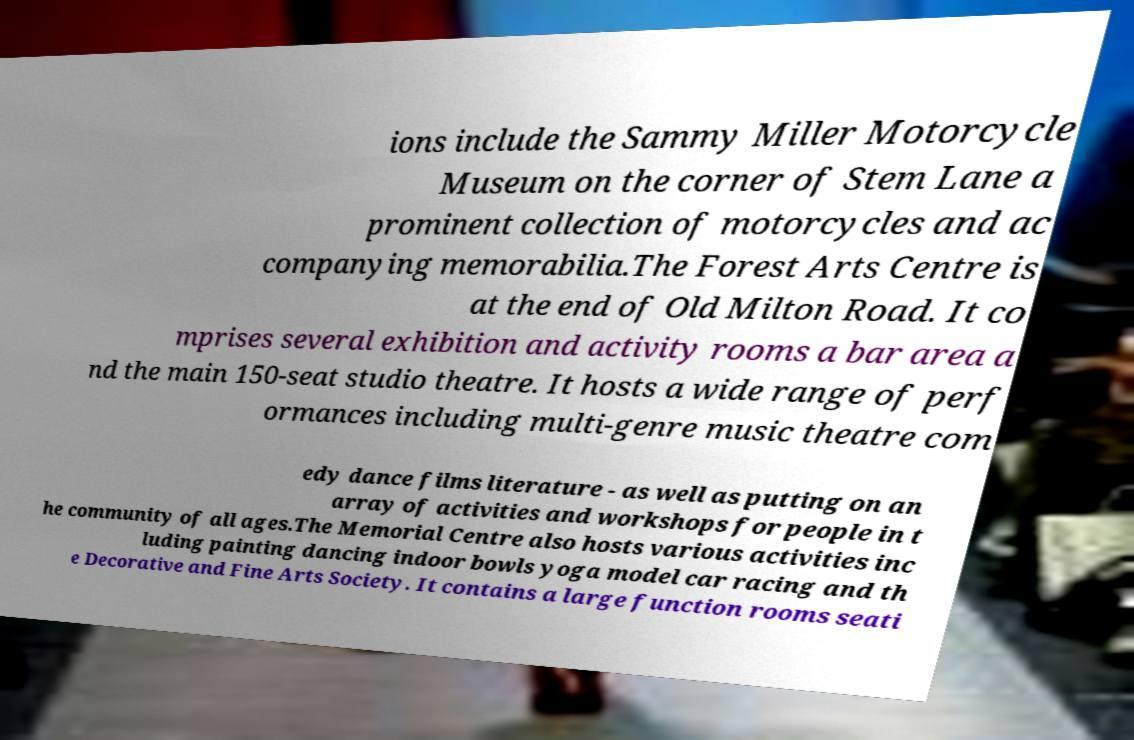Could you extract and type out the text from this image? ions include the Sammy Miller Motorcycle Museum on the corner of Stem Lane a prominent collection of motorcycles and ac companying memorabilia.The Forest Arts Centre is at the end of Old Milton Road. It co mprises several exhibition and activity rooms a bar area a nd the main 150-seat studio theatre. It hosts a wide range of perf ormances including multi-genre music theatre com edy dance films literature - as well as putting on an array of activities and workshops for people in t he community of all ages.The Memorial Centre also hosts various activities inc luding painting dancing indoor bowls yoga model car racing and th e Decorative and Fine Arts Society. It contains a large function rooms seati 